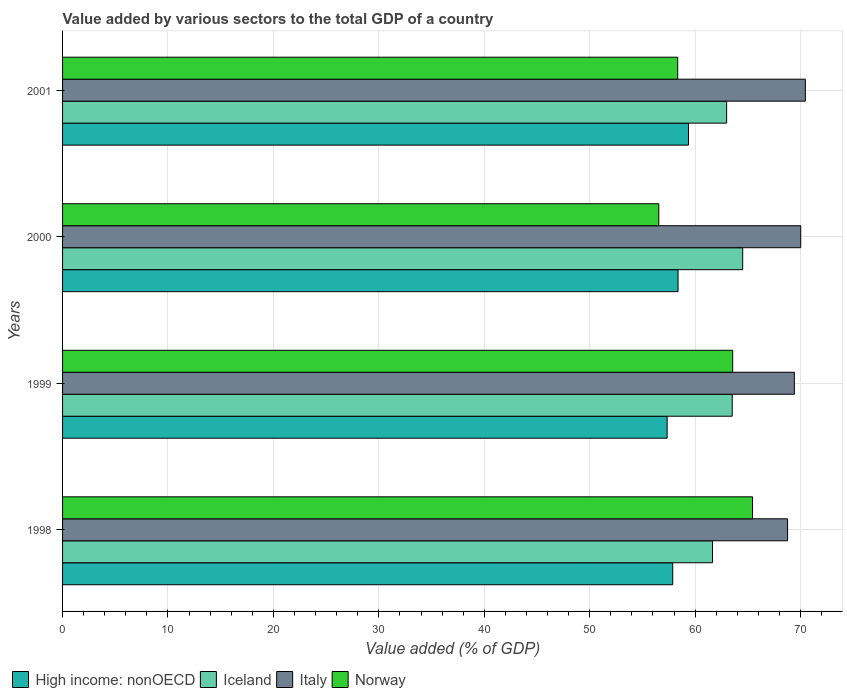How many different coloured bars are there?
Your answer should be compact. 4. How many groups of bars are there?
Offer a very short reply. 4. What is the value added by various sectors to the total GDP in High income: nonOECD in 2001?
Provide a short and direct response. 59.37. Across all years, what is the maximum value added by various sectors to the total GDP in High income: nonOECD?
Provide a short and direct response. 59.37. Across all years, what is the minimum value added by various sectors to the total GDP in Norway?
Keep it short and to the point. 56.56. In which year was the value added by various sectors to the total GDP in Italy maximum?
Your answer should be compact. 2001. What is the total value added by various sectors to the total GDP in Norway in the graph?
Give a very brief answer. 243.91. What is the difference between the value added by various sectors to the total GDP in Italy in 1998 and that in 1999?
Offer a very short reply. -0.64. What is the difference between the value added by various sectors to the total GDP in Iceland in 2000 and the value added by various sectors to the total GDP in Italy in 2001?
Offer a very short reply. -5.94. What is the average value added by various sectors to the total GDP in Italy per year?
Ensure brevity in your answer.  69.66. In the year 1999, what is the difference between the value added by various sectors to the total GDP in Iceland and value added by various sectors to the total GDP in Italy?
Your response must be concise. -5.89. In how many years, is the value added by various sectors to the total GDP in Italy greater than 10 %?
Your answer should be very brief. 4. What is the ratio of the value added by various sectors to the total GDP in High income: nonOECD in 1998 to that in 1999?
Provide a short and direct response. 1.01. Is the value added by various sectors to the total GDP in Iceland in 2000 less than that in 2001?
Your answer should be very brief. No. Is the difference between the value added by various sectors to the total GDP in Iceland in 1999 and 2000 greater than the difference between the value added by various sectors to the total GDP in Italy in 1999 and 2000?
Your answer should be very brief. No. What is the difference between the highest and the second highest value added by various sectors to the total GDP in Norway?
Provide a short and direct response. 1.88. What is the difference between the highest and the lowest value added by various sectors to the total GDP in Italy?
Offer a terse response. 1.69. What does the 2nd bar from the top in 1999 represents?
Offer a terse response. Italy. What does the 2nd bar from the bottom in 1998 represents?
Your answer should be very brief. Iceland. Are all the bars in the graph horizontal?
Your answer should be compact. Yes. Does the graph contain any zero values?
Provide a short and direct response. No. Does the graph contain grids?
Provide a short and direct response. Yes. How many legend labels are there?
Your response must be concise. 4. What is the title of the graph?
Offer a very short reply. Value added by various sectors to the total GDP of a country. Does "Sub-Saharan Africa (all income levels)" appear as one of the legend labels in the graph?
Your response must be concise. No. What is the label or title of the X-axis?
Give a very brief answer. Value added (% of GDP). What is the Value added (% of GDP) of High income: nonOECD in 1998?
Your response must be concise. 57.88. What is the Value added (% of GDP) in Iceland in 1998?
Your answer should be compact. 61.65. What is the Value added (% of GDP) in Italy in 1998?
Offer a terse response. 68.77. What is the Value added (% of GDP) of Norway in 1998?
Make the answer very short. 65.44. What is the Value added (% of GDP) in High income: nonOECD in 1999?
Keep it short and to the point. 57.34. What is the Value added (% of GDP) of Iceland in 1999?
Make the answer very short. 63.52. What is the Value added (% of GDP) of Italy in 1999?
Your response must be concise. 69.41. What is the Value added (% of GDP) of Norway in 1999?
Ensure brevity in your answer.  63.56. What is the Value added (% of GDP) in High income: nonOECD in 2000?
Provide a succinct answer. 58.38. What is the Value added (% of GDP) in Iceland in 2000?
Ensure brevity in your answer.  64.51. What is the Value added (% of GDP) of Italy in 2000?
Give a very brief answer. 70.02. What is the Value added (% of GDP) of Norway in 2000?
Your answer should be very brief. 56.56. What is the Value added (% of GDP) of High income: nonOECD in 2001?
Offer a very short reply. 59.37. What is the Value added (% of GDP) of Iceland in 2001?
Your response must be concise. 62.99. What is the Value added (% of GDP) in Italy in 2001?
Provide a succinct answer. 70.46. What is the Value added (% of GDP) in Norway in 2001?
Provide a short and direct response. 58.35. Across all years, what is the maximum Value added (% of GDP) of High income: nonOECD?
Offer a terse response. 59.37. Across all years, what is the maximum Value added (% of GDP) in Iceland?
Ensure brevity in your answer.  64.51. Across all years, what is the maximum Value added (% of GDP) in Italy?
Provide a succinct answer. 70.46. Across all years, what is the maximum Value added (% of GDP) in Norway?
Make the answer very short. 65.44. Across all years, what is the minimum Value added (% of GDP) in High income: nonOECD?
Keep it short and to the point. 57.34. Across all years, what is the minimum Value added (% of GDP) in Iceland?
Keep it short and to the point. 61.65. Across all years, what is the minimum Value added (% of GDP) in Italy?
Your answer should be compact. 68.77. Across all years, what is the minimum Value added (% of GDP) of Norway?
Provide a short and direct response. 56.56. What is the total Value added (% of GDP) of High income: nonOECD in the graph?
Give a very brief answer. 232.97. What is the total Value added (% of GDP) in Iceland in the graph?
Your answer should be very brief. 252.67. What is the total Value added (% of GDP) of Italy in the graph?
Your answer should be very brief. 278.66. What is the total Value added (% of GDP) in Norway in the graph?
Your answer should be very brief. 243.91. What is the difference between the Value added (% of GDP) of High income: nonOECD in 1998 and that in 1999?
Give a very brief answer. 0.53. What is the difference between the Value added (% of GDP) of Iceland in 1998 and that in 1999?
Make the answer very short. -1.87. What is the difference between the Value added (% of GDP) of Italy in 1998 and that in 1999?
Provide a succinct answer. -0.64. What is the difference between the Value added (% of GDP) of Norway in 1998 and that in 1999?
Offer a very short reply. 1.88. What is the difference between the Value added (% of GDP) in High income: nonOECD in 1998 and that in 2000?
Give a very brief answer. -0.51. What is the difference between the Value added (% of GDP) of Iceland in 1998 and that in 2000?
Make the answer very short. -2.87. What is the difference between the Value added (% of GDP) of Italy in 1998 and that in 2000?
Make the answer very short. -1.25. What is the difference between the Value added (% of GDP) in Norway in 1998 and that in 2000?
Make the answer very short. 8.89. What is the difference between the Value added (% of GDP) in High income: nonOECD in 1998 and that in 2001?
Make the answer very short. -1.49. What is the difference between the Value added (% of GDP) of Iceland in 1998 and that in 2001?
Your response must be concise. -1.34. What is the difference between the Value added (% of GDP) of Italy in 1998 and that in 2001?
Your answer should be very brief. -1.69. What is the difference between the Value added (% of GDP) of Norway in 1998 and that in 2001?
Offer a very short reply. 7.1. What is the difference between the Value added (% of GDP) of High income: nonOECD in 1999 and that in 2000?
Offer a very short reply. -1.04. What is the difference between the Value added (% of GDP) of Iceland in 1999 and that in 2000?
Keep it short and to the point. -0.99. What is the difference between the Value added (% of GDP) of Italy in 1999 and that in 2000?
Make the answer very short. -0.61. What is the difference between the Value added (% of GDP) of Norway in 1999 and that in 2000?
Give a very brief answer. 7.01. What is the difference between the Value added (% of GDP) in High income: nonOECD in 1999 and that in 2001?
Make the answer very short. -2.03. What is the difference between the Value added (% of GDP) in Iceland in 1999 and that in 2001?
Keep it short and to the point. 0.53. What is the difference between the Value added (% of GDP) of Italy in 1999 and that in 2001?
Offer a terse response. -1.04. What is the difference between the Value added (% of GDP) in Norway in 1999 and that in 2001?
Offer a terse response. 5.22. What is the difference between the Value added (% of GDP) in High income: nonOECD in 2000 and that in 2001?
Offer a very short reply. -0.99. What is the difference between the Value added (% of GDP) in Iceland in 2000 and that in 2001?
Offer a terse response. 1.52. What is the difference between the Value added (% of GDP) in Italy in 2000 and that in 2001?
Ensure brevity in your answer.  -0.44. What is the difference between the Value added (% of GDP) in Norway in 2000 and that in 2001?
Your answer should be very brief. -1.79. What is the difference between the Value added (% of GDP) of High income: nonOECD in 1998 and the Value added (% of GDP) of Iceland in 1999?
Give a very brief answer. -5.64. What is the difference between the Value added (% of GDP) of High income: nonOECD in 1998 and the Value added (% of GDP) of Italy in 1999?
Provide a succinct answer. -11.54. What is the difference between the Value added (% of GDP) in High income: nonOECD in 1998 and the Value added (% of GDP) in Norway in 1999?
Your response must be concise. -5.69. What is the difference between the Value added (% of GDP) of Iceland in 1998 and the Value added (% of GDP) of Italy in 1999?
Provide a succinct answer. -7.77. What is the difference between the Value added (% of GDP) of Iceland in 1998 and the Value added (% of GDP) of Norway in 1999?
Make the answer very short. -1.92. What is the difference between the Value added (% of GDP) of Italy in 1998 and the Value added (% of GDP) of Norway in 1999?
Your answer should be very brief. 5.21. What is the difference between the Value added (% of GDP) in High income: nonOECD in 1998 and the Value added (% of GDP) in Iceland in 2000?
Keep it short and to the point. -6.64. What is the difference between the Value added (% of GDP) in High income: nonOECD in 1998 and the Value added (% of GDP) in Italy in 2000?
Make the answer very short. -12.14. What is the difference between the Value added (% of GDP) of High income: nonOECD in 1998 and the Value added (% of GDP) of Norway in 2000?
Make the answer very short. 1.32. What is the difference between the Value added (% of GDP) of Iceland in 1998 and the Value added (% of GDP) of Italy in 2000?
Your response must be concise. -8.37. What is the difference between the Value added (% of GDP) of Iceland in 1998 and the Value added (% of GDP) of Norway in 2000?
Give a very brief answer. 5.09. What is the difference between the Value added (% of GDP) in Italy in 1998 and the Value added (% of GDP) in Norway in 2000?
Ensure brevity in your answer.  12.21. What is the difference between the Value added (% of GDP) of High income: nonOECD in 1998 and the Value added (% of GDP) of Iceland in 2001?
Ensure brevity in your answer.  -5.11. What is the difference between the Value added (% of GDP) in High income: nonOECD in 1998 and the Value added (% of GDP) in Italy in 2001?
Provide a short and direct response. -12.58. What is the difference between the Value added (% of GDP) of High income: nonOECD in 1998 and the Value added (% of GDP) of Norway in 2001?
Keep it short and to the point. -0.47. What is the difference between the Value added (% of GDP) in Iceland in 1998 and the Value added (% of GDP) in Italy in 2001?
Ensure brevity in your answer.  -8.81. What is the difference between the Value added (% of GDP) of Iceland in 1998 and the Value added (% of GDP) of Norway in 2001?
Make the answer very short. 3.3. What is the difference between the Value added (% of GDP) of Italy in 1998 and the Value added (% of GDP) of Norway in 2001?
Provide a short and direct response. 10.42. What is the difference between the Value added (% of GDP) of High income: nonOECD in 1999 and the Value added (% of GDP) of Iceland in 2000?
Give a very brief answer. -7.17. What is the difference between the Value added (% of GDP) of High income: nonOECD in 1999 and the Value added (% of GDP) of Italy in 2000?
Provide a short and direct response. -12.67. What is the difference between the Value added (% of GDP) of High income: nonOECD in 1999 and the Value added (% of GDP) of Norway in 2000?
Make the answer very short. 0.79. What is the difference between the Value added (% of GDP) of Iceland in 1999 and the Value added (% of GDP) of Italy in 2000?
Provide a short and direct response. -6.5. What is the difference between the Value added (% of GDP) of Iceland in 1999 and the Value added (% of GDP) of Norway in 2000?
Keep it short and to the point. 6.96. What is the difference between the Value added (% of GDP) in Italy in 1999 and the Value added (% of GDP) in Norway in 2000?
Your answer should be very brief. 12.86. What is the difference between the Value added (% of GDP) in High income: nonOECD in 1999 and the Value added (% of GDP) in Iceland in 2001?
Ensure brevity in your answer.  -5.64. What is the difference between the Value added (% of GDP) in High income: nonOECD in 1999 and the Value added (% of GDP) in Italy in 2001?
Give a very brief answer. -13.11. What is the difference between the Value added (% of GDP) in High income: nonOECD in 1999 and the Value added (% of GDP) in Norway in 2001?
Provide a short and direct response. -1. What is the difference between the Value added (% of GDP) of Iceland in 1999 and the Value added (% of GDP) of Italy in 2001?
Offer a very short reply. -6.94. What is the difference between the Value added (% of GDP) of Iceland in 1999 and the Value added (% of GDP) of Norway in 2001?
Your response must be concise. 5.17. What is the difference between the Value added (% of GDP) of Italy in 1999 and the Value added (% of GDP) of Norway in 2001?
Offer a very short reply. 11.06. What is the difference between the Value added (% of GDP) of High income: nonOECD in 2000 and the Value added (% of GDP) of Iceland in 2001?
Provide a succinct answer. -4.61. What is the difference between the Value added (% of GDP) in High income: nonOECD in 2000 and the Value added (% of GDP) in Italy in 2001?
Your answer should be compact. -12.07. What is the difference between the Value added (% of GDP) in High income: nonOECD in 2000 and the Value added (% of GDP) in Norway in 2001?
Offer a very short reply. 0.03. What is the difference between the Value added (% of GDP) in Iceland in 2000 and the Value added (% of GDP) in Italy in 2001?
Your answer should be compact. -5.94. What is the difference between the Value added (% of GDP) of Iceland in 2000 and the Value added (% of GDP) of Norway in 2001?
Your response must be concise. 6.16. What is the difference between the Value added (% of GDP) of Italy in 2000 and the Value added (% of GDP) of Norway in 2001?
Provide a succinct answer. 11.67. What is the average Value added (% of GDP) in High income: nonOECD per year?
Keep it short and to the point. 58.24. What is the average Value added (% of GDP) of Iceland per year?
Your answer should be very brief. 63.17. What is the average Value added (% of GDP) of Italy per year?
Offer a terse response. 69.66. What is the average Value added (% of GDP) of Norway per year?
Provide a short and direct response. 60.98. In the year 1998, what is the difference between the Value added (% of GDP) in High income: nonOECD and Value added (% of GDP) in Iceland?
Keep it short and to the point. -3.77. In the year 1998, what is the difference between the Value added (% of GDP) of High income: nonOECD and Value added (% of GDP) of Italy?
Your response must be concise. -10.89. In the year 1998, what is the difference between the Value added (% of GDP) in High income: nonOECD and Value added (% of GDP) in Norway?
Keep it short and to the point. -7.57. In the year 1998, what is the difference between the Value added (% of GDP) of Iceland and Value added (% of GDP) of Italy?
Make the answer very short. -7.12. In the year 1998, what is the difference between the Value added (% of GDP) of Iceland and Value added (% of GDP) of Norway?
Your answer should be very brief. -3.8. In the year 1998, what is the difference between the Value added (% of GDP) of Italy and Value added (% of GDP) of Norway?
Provide a short and direct response. 3.33. In the year 1999, what is the difference between the Value added (% of GDP) in High income: nonOECD and Value added (% of GDP) in Iceland?
Your answer should be compact. -6.17. In the year 1999, what is the difference between the Value added (% of GDP) of High income: nonOECD and Value added (% of GDP) of Italy?
Your answer should be very brief. -12.07. In the year 1999, what is the difference between the Value added (% of GDP) in High income: nonOECD and Value added (% of GDP) in Norway?
Provide a short and direct response. -6.22. In the year 1999, what is the difference between the Value added (% of GDP) in Iceland and Value added (% of GDP) in Italy?
Keep it short and to the point. -5.89. In the year 1999, what is the difference between the Value added (% of GDP) of Iceland and Value added (% of GDP) of Norway?
Offer a terse response. -0.05. In the year 1999, what is the difference between the Value added (% of GDP) of Italy and Value added (% of GDP) of Norway?
Your response must be concise. 5.85. In the year 2000, what is the difference between the Value added (% of GDP) in High income: nonOECD and Value added (% of GDP) in Iceland?
Make the answer very short. -6.13. In the year 2000, what is the difference between the Value added (% of GDP) of High income: nonOECD and Value added (% of GDP) of Italy?
Your response must be concise. -11.63. In the year 2000, what is the difference between the Value added (% of GDP) in High income: nonOECD and Value added (% of GDP) in Norway?
Offer a very short reply. 1.83. In the year 2000, what is the difference between the Value added (% of GDP) in Iceland and Value added (% of GDP) in Italy?
Give a very brief answer. -5.51. In the year 2000, what is the difference between the Value added (% of GDP) in Iceland and Value added (% of GDP) in Norway?
Provide a succinct answer. 7.96. In the year 2000, what is the difference between the Value added (% of GDP) in Italy and Value added (% of GDP) in Norway?
Give a very brief answer. 13.46. In the year 2001, what is the difference between the Value added (% of GDP) of High income: nonOECD and Value added (% of GDP) of Iceland?
Your response must be concise. -3.62. In the year 2001, what is the difference between the Value added (% of GDP) in High income: nonOECD and Value added (% of GDP) in Italy?
Make the answer very short. -11.09. In the year 2001, what is the difference between the Value added (% of GDP) of High income: nonOECD and Value added (% of GDP) of Norway?
Make the answer very short. 1.02. In the year 2001, what is the difference between the Value added (% of GDP) of Iceland and Value added (% of GDP) of Italy?
Offer a very short reply. -7.47. In the year 2001, what is the difference between the Value added (% of GDP) in Iceland and Value added (% of GDP) in Norway?
Keep it short and to the point. 4.64. In the year 2001, what is the difference between the Value added (% of GDP) of Italy and Value added (% of GDP) of Norway?
Give a very brief answer. 12.11. What is the ratio of the Value added (% of GDP) in High income: nonOECD in 1998 to that in 1999?
Give a very brief answer. 1.01. What is the ratio of the Value added (% of GDP) of Iceland in 1998 to that in 1999?
Offer a very short reply. 0.97. What is the ratio of the Value added (% of GDP) in Italy in 1998 to that in 1999?
Ensure brevity in your answer.  0.99. What is the ratio of the Value added (% of GDP) of Norway in 1998 to that in 1999?
Ensure brevity in your answer.  1.03. What is the ratio of the Value added (% of GDP) of High income: nonOECD in 1998 to that in 2000?
Your answer should be very brief. 0.99. What is the ratio of the Value added (% of GDP) of Iceland in 1998 to that in 2000?
Make the answer very short. 0.96. What is the ratio of the Value added (% of GDP) in Italy in 1998 to that in 2000?
Your answer should be compact. 0.98. What is the ratio of the Value added (% of GDP) of Norway in 1998 to that in 2000?
Your answer should be compact. 1.16. What is the ratio of the Value added (% of GDP) in High income: nonOECD in 1998 to that in 2001?
Keep it short and to the point. 0.97. What is the ratio of the Value added (% of GDP) in Iceland in 1998 to that in 2001?
Provide a short and direct response. 0.98. What is the ratio of the Value added (% of GDP) of Italy in 1998 to that in 2001?
Make the answer very short. 0.98. What is the ratio of the Value added (% of GDP) in Norway in 1998 to that in 2001?
Your answer should be very brief. 1.12. What is the ratio of the Value added (% of GDP) of High income: nonOECD in 1999 to that in 2000?
Offer a terse response. 0.98. What is the ratio of the Value added (% of GDP) of Iceland in 1999 to that in 2000?
Keep it short and to the point. 0.98. What is the ratio of the Value added (% of GDP) in Norway in 1999 to that in 2000?
Ensure brevity in your answer.  1.12. What is the ratio of the Value added (% of GDP) in High income: nonOECD in 1999 to that in 2001?
Provide a succinct answer. 0.97. What is the ratio of the Value added (% of GDP) of Iceland in 1999 to that in 2001?
Your answer should be very brief. 1.01. What is the ratio of the Value added (% of GDP) in Italy in 1999 to that in 2001?
Ensure brevity in your answer.  0.99. What is the ratio of the Value added (% of GDP) in Norway in 1999 to that in 2001?
Keep it short and to the point. 1.09. What is the ratio of the Value added (% of GDP) of High income: nonOECD in 2000 to that in 2001?
Offer a terse response. 0.98. What is the ratio of the Value added (% of GDP) of Iceland in 2000 to that in 2001?
Your answer should be compact. 1.02. What is the ratio of the Value added (% of GDP) of Norway in 2000 to that in 2001?
Offer a very short reply. 0.97. What is the difference between the highest and the second highest Value added (% of GDP) in High income: nonOECD?
Offer a terse response. 0.99. What is the difference between the highest and the second highest Value added (% of GDP) of Italy?
Your answer should be very brief. 0.44. What is the difference between the highest and the second highest Value added (% of GDP) of Norway?
Keep it short and to the point. 1.88. What is the difference between the highest and the lowest Value added (% of GDP) in High income: nonOECD?
Provide a short and direct response. 2.03. What is the difference between the highest and the lowest Value added (% of GDP) in Iceland?
Ensure brevity in your answer.  2.87. What is the difference between the highest and the lowest Value added (% of GDP) of Italy?
Keep it short and to the point. 1.69. What is the difference between the highest and the lowest Value added (% of GDP) in Norway?
Give a very brief answer. 8.89. 